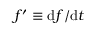Convert formula to latex. <formula><loc_0><loc_0><loc_500><loc_500>f ^ { \prime } \equiv d f / { d } t</formula> 